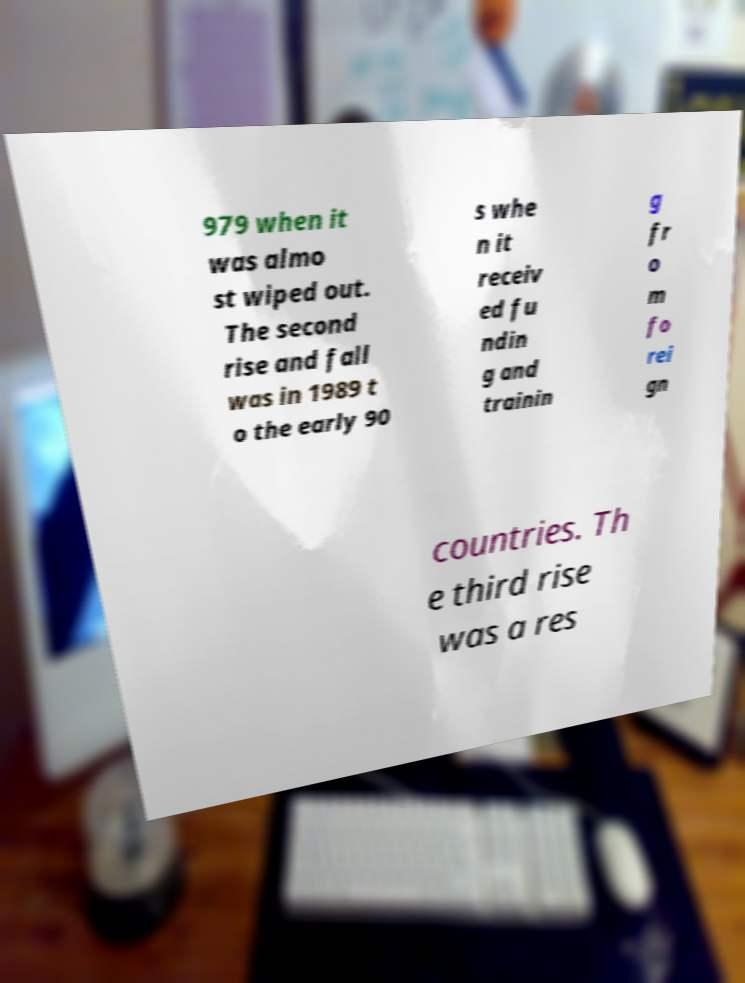There's text embedded in this image that I need extracted. Can you transcribe it verbatim? 979 when it was almo st wiped out. The second rise and fall was in 1989 t o the early 90 s whe n it receiv ed fu ndin g and trainin g fr o m fo rei gn countries. Th e third rise was a res 